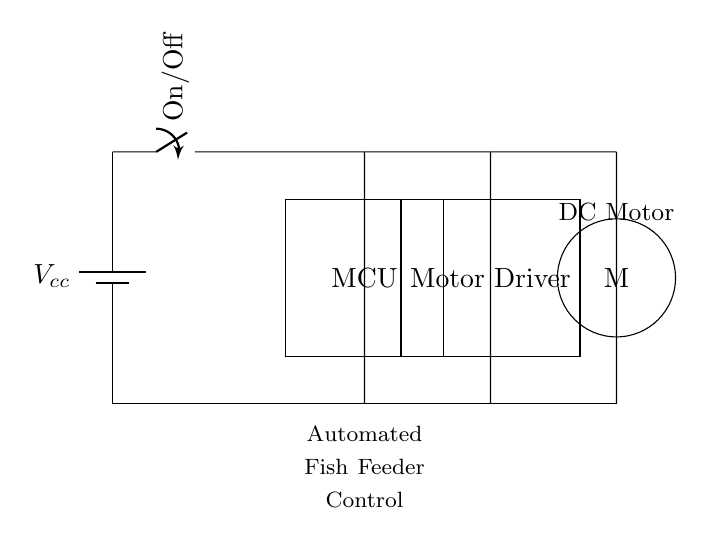What is the power supply component in this circuit? The power supply component is the battery labeled as Vcc, which provides the necessary voltage for the circuit to function.
Answer: Vcc What type of control device is used in this circuit? The control device used is a microcontroller (MCU), which processes the control signals to manage the automated fish feeder.
Answer: Microcontroller How many main components are visible in the circuit diagram? The diagram shows four main components: the power supply, switch, microcontroller, and motor driver with the DC motor.
Answer: Four What is the role of the motor driver in this circuit? The motor driver acts as an interface between the microcontroller and the DC motor, allowing the microcontroller to control the motor's operation without directly powering the motor itself.
Answer: Interface What type of circuit is depicted in this diagram? This circuit is a series circuit, meaning all components are connected end-to-end in a single path, and the current flows through each component sequentially.
Answer: Series What happens when the switch is in the "On" position? When the switch is "On," the circuit completes, allowing current to flow from the power supply through the microcontroller, motor driver, and DC motor, hence activating the fish feeder.
Answer: Current flows How does the microcontroller interact with the motor in this circuit? The microcontroller sends control signals to the motor driver, which then regulates the power to the DC motor based on the programmed feeding schedule.
Answer: Sends control signals 